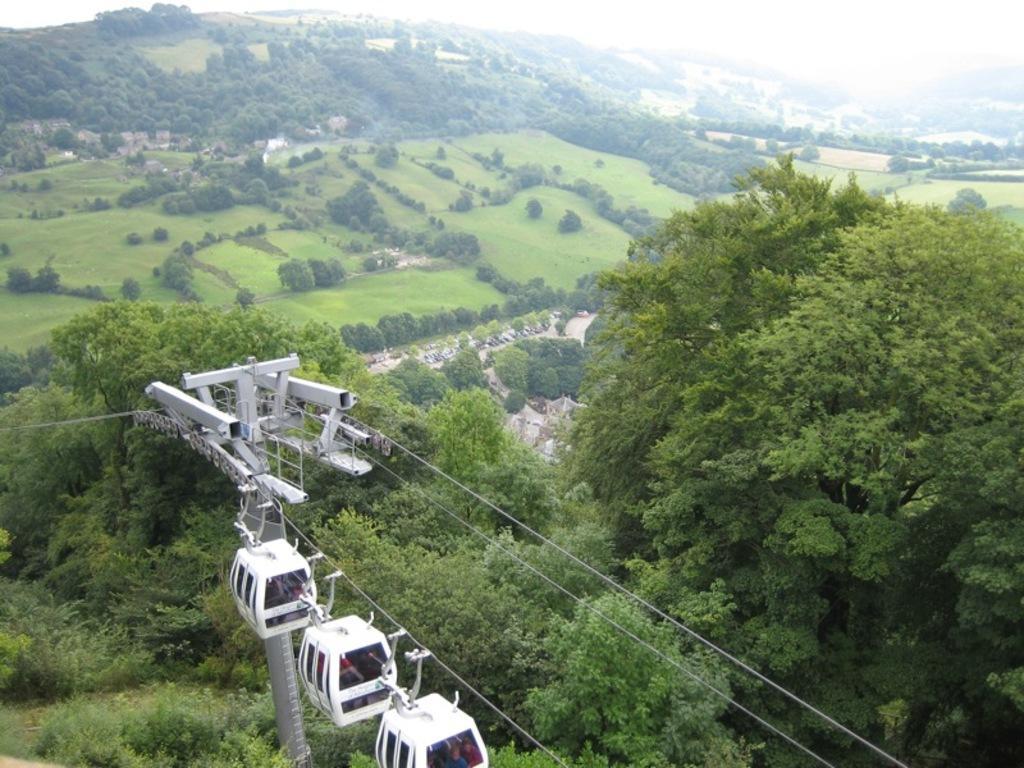Please provide a concise description of this image. In this picture we can see the ropeway, pole, trees, hill and the sky. 